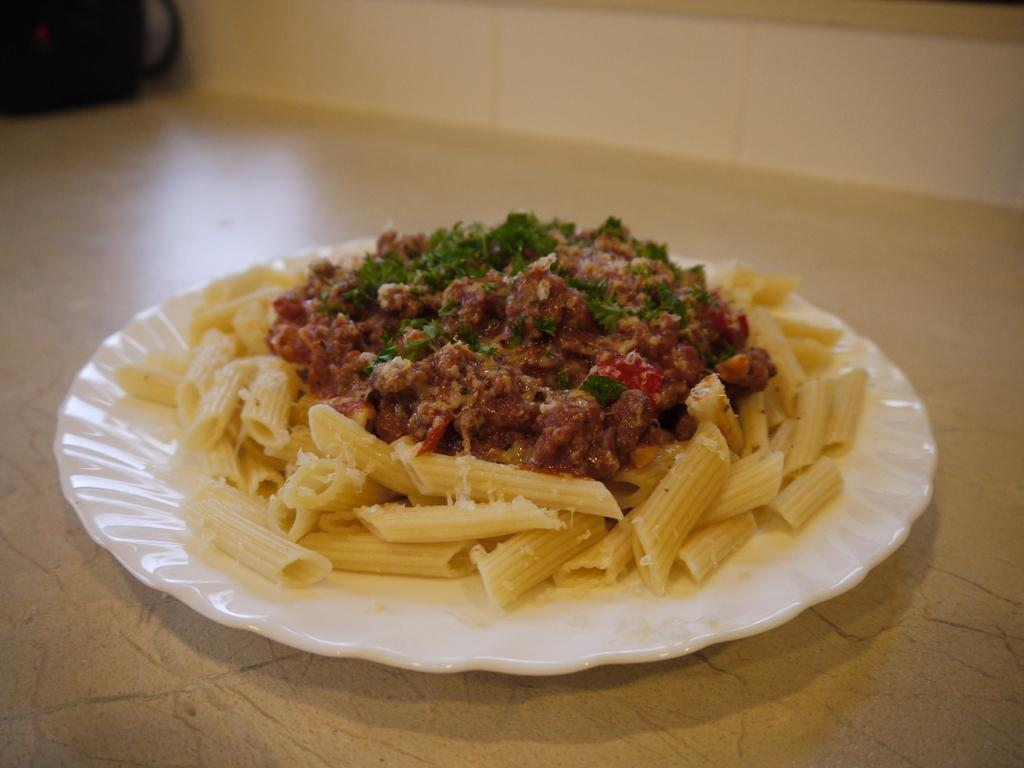What is the main subject in the center of the image? There is a plate with food in the center of the image. Where is the plate located? The plate is on the floor. What can be seen at the top of the image? There is a wall visible at the top of the image. What else is present in the image? There is a cup in the top left corner of the image. What is the tendency of the geese in the image? There are no geese present in the image, so it is not possible to determine their tendency. 